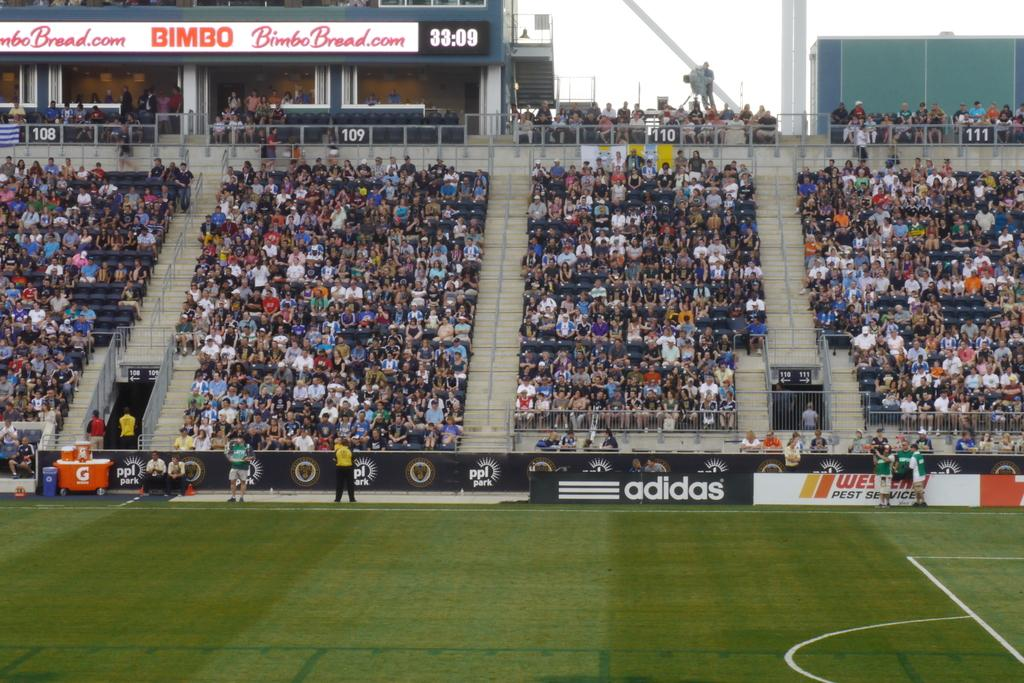<image>
Write a terse but informative summary of the picture. The low walls of an athletic stadium are full of ads for companies like Adidas and Western Pest Services. 